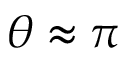<formula> <loc_0><loc_0><loc_500><loc_500>\theta \approx \pi</formula> 